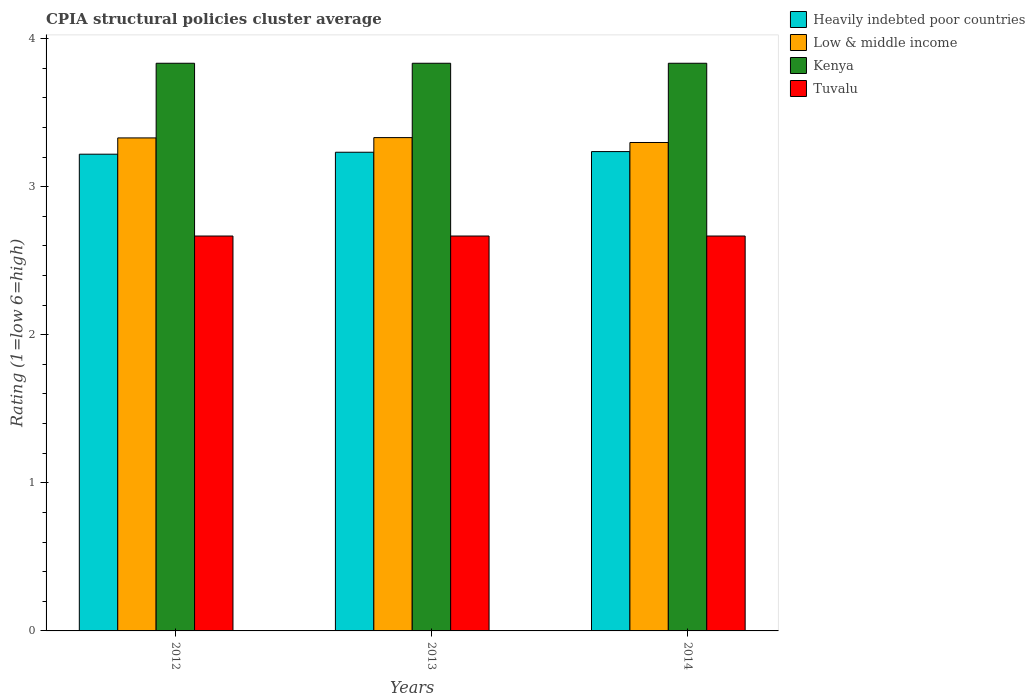How many different coloured bars are there?
Your answer should be very brief. 4. Are the number of bars per tick equal to the number of legend labels?
Your answer should be compact. Yes. How many bars are there on the 2nd tick from the right?
Give a very brief answer. 4. In how many cases, is the number of bars for a given year not equal to the number of legend labels?
Offer a terse response. 0. What is the CPIA rating in Low & middle income in 2012?
Your answer should be very brief. 3.33. Across all years, what is the maximum CPIA rating in Kenya?
Offer a terse response. 3.83. Across all years, what is the minimum CPIA rating in Kenya?
Your answer should be compact. 3.83. What is the total CPIA rating in Kenya in the graph?
Keep it short and to the point. 11.5. What is the difference between the CPIA rating in Tuvalu in 2013 and that in 2014?
Offer a terse response. -3.333333329802457e-6. What is the difference between the CPIA rating in Kenya in 2014 and the CPIA rating in Tuvalu in 2012?
Offer a very short reply. 1.17. What is the average CPIA rating in Heavily indebted poor countries per year?
Make the answer very short. 3.23. In the year 2014, what is the difference between the CPIA rating in Tuvalu and CPIA rating in Heavily indebted poor countries?
Offer a very short reply. -0.57. In how many years, is the CPIA rating in Tuvalu greater than 1.2?
Keep it short and to the point. 3. What is the ratio of the CPIA rating in Kenya in 2012 to that in 2013?
Your response must be concise. 1. Is the difference between the CPIA rating in Tuvalu in 2012 and 2014 greater than the difference between the CPIA rating in Heavily indebted poor countries in 2012 and 2014?
Your answer should be very brief. Yes. What is the difference between the highest and the lowest CPIA rating in Low & middle income?
Make the answer very short. 0.03. What does the 4th bar from the left in 2012 represents?
Provide a short and direct response. Tuvalu. What does the 2nd bar from the right in 2013 represents?
Give a very brief answer. Kenya. Is it the case that in every year, the sum of the CPIA rating in Low & middle income and CPIA rating in Tuvalu is greater than the CPIA rating in Heavily indebted poor countries?
Your answer should be very brief. Yes. Are all the bars in the graph horizontal?
Provide a succinct answer. No. Does the graph contain grids?
Provide a succinct answer. No. Where does the legend appear in the graph?
Offer a terse response. Top right. What is the title of the graph?
Provide a succinct answer. CPIA structural policies cluster average. What is the label or title of the Y-axis?
Give a very brief answer. Rating (1=low 6=high). What is the Rating (1=low 6=high) in Heavily indebted poor countries in 2012?
Give a very brief answer. 3.22. What is the Rating (1=low 6=high) of Low & middle income in 2012?
Provide a short and direct response. 3.33. What is the Rating (1=low 6=high) in Kenya in 2012?
Provide a short and direct response. 3.83. What is the Rating (1=low 6=high) in Tuvalu in 2012?
Offer a terse response. 2.67. What is the Rating (1=low 6=high) of Heavily indebted poor countries in 2013?
Your answer should be compact. 3.23. What is the Rating (1=low 6=high) in Low & middle income in 2013?
Provide a succinct answer. 3.33. What is the Rating (1=low 6=high) of Kenya in 2013?
Your response must be concise. 3.83. What is the Rating (1=low 6=high) of Tuvalu in 2013?
Provide a succinct answer. 2.67. What is the Rating (1=low 6=high) of Heavily indebted poor countries in 2014?
Keep it short and to the point. 3.24. What is the Rating (1=low 6=high) of Low & middle income in 2014?
Offer a terse response. 3.3. What is the Rating (1=low 6=high) of Kenya in 2014?
Offer a very short reply. 3.83. What is the Rating (1=low 6=high) in Tuvalu in 2014?
Provide a succinct answer. 2.67. Across all years, what is the maximum Rating (1=low 6=high) of Heavily indebted poor countries?
Your answer should be very brief. 3.24. Across all years, what is the maximum Rating (1=low 6=high) in Low & middle income?
Keep it short and to the point. 3.33. Across all years, what is the maximum Rating (1=low 6=high) in Kenya?
Ensure brevity in your answer.  3.83. Across all years, what is the maximum Rating (1=low 6=high) in Tuvalu?
Give a very brief answer. 2.67. Across all years, what is the minimum Rating (1=low 6=high) in Heavily indebted poor countries?
Offer a terse response. 3.22. Across all years, what is the minimum Rating (1=low 6=high) in Low & middle income?
Offer a very short reply. 3.3. Across all years, what is the minimum Rating (1=low 6=high) in Kenya?
Keep it short and to the point. 3.83. Across all years, what is the minimum Rating (1=low 6=high) in Tuvalu?
Your answer should be compact. 2.67. What is the total Rating (1=low 6=high) in Heavily indebted poor countries in the graph?
Ensure brevity in your answer.  9.69. What is the total Rating (1=low 6=high) of Low & middle income in the graph?
Keep it short and to the point. 9.96. What is the total Rating (1=low 6=high) of Kenya in the graph?
Ensure brevity in your answer.  11.5. What is the total Rating (1=low 6=high) in Tuvalu in the graph?
Keep it short and to the point. 8. What is the difference between the Rating (1=low 6=high) in Heavily indebted poor countries in 2012 and that in 2013?
Your response must be concise. -0.01. What is the difference between the Rating (1=low 6=high) in Low & middle income in 2012 and that in 2013?
Keep it short and to the point. -0. What is the difference between the Rating (1=low 6=high) of Kenya in 2012 and that in 2013?
Ensure brevity in your answer.  0. What is the difference between the Rating (1=low 6=high) in Tuvalu in 2012 and that in 2013?
Provide a short and direct response. 0. What is the difference between the Rating (1=low 6=high) of Heavily indebted poor countries in 2012 and that in 2014?
Give a very brief answer. -0.02. What is the difference between the Rating (1=low 6=high) in Low & middle income in 2012 and that in 2014?
Provide a succinct answer. 0.03. What is the difference between the Rating (1=low 6=high) of Heavily indebted poor countries in 2013 and that in 2014?
Your answer should be compact. -0. What is the difference between the Rating (1=low 6=high) of Low & middle income in 2013 and that in 2014?
Ensure brevity in your answer.  0.03. What is the difference between the Rating (1=low 6=high) of Tuvalu in 2013 and that in 2014?
Make the answer very short. -0. What is the difference between the Rating (1=low 6=high) in Heavily indebted poor countries in 2012 and the Rating (1=low 6=high) in Low & middle income in 2013?
Your answer should be compact. -0.11. What is the difference between the Rating (1=low 6=high) of Heavily indebted poor countries in 2012 and the Rating (1=low 6=high) of Kenya in 2013?
Offer a terse response. -0.61. What is the difference between the Rating (1=low 6=high) in Heavily indebted poor countries in 2012 and the Rating (1=low 6=high) in Tuvalu in 2013?
Your answer should be very brief. 0.55. What is the difference between the Rating (1=low 6=high) of Low & middle income in 2012 and the Rating (1=low 6=high) of Kenya in 2013?
Keep it short and to the point. -0.5. What is the difference between the Rating (1=low 6=high) in Low & middle income in 2012 and the Rating (1=low 6=high) in Tuvalu in 2013?
Ensure brevity in your answer.  0.66. What is the difference between the Rating (1=low 6=high) of Kenya in 2012 and the Rating (1=low 6=high) of Tuvalu in 2013?
Keep it short and to the point. 1.17. What is the difference between the Rating (1=low 6=high) of Heavily indebted poor countries in 2012 and the Rating (1=low 6=high) of Low & middle income in 2014?
Your answer should be very brief. -0.08. What is the difference between the Rating (1=low 6=high) of Heavily indebted poor countries in 2012 and the Rating (1=low 6=high) of Kenya in 2014?
Provide a short and direct response. -0.61. What is the difference between the Rating (1=low 6=high) in Heavily indebted poor countries in 2012 and the Rating (1=low 6=high) in Tuvalu in 2014?
Offer a terse response. 0.55. What is the difference between the Rating (1=low 6=high) of Low & middle income in 2012 and the Rating (1=low 6=high) of Kenya in 2014?
Offer a very short reply. -0.5. What is the difference between the Rating (1=low 6=high) in Low & middle income in 2012 and the Rating (1=low 6=high) in Tuvalu in 2014?
Provide a succinct answer. 0.66. What is the difference between the Rating (1=low 6=high) in Heavily indebted poor countries in 2013 and the Rating (1=low 6=high) in Low & middle income in 2014?
Your answer should be very brief. -0.07. What is the difference between the Rating (1=low 6=high) in Heavily indebted poor countries in 2013 and the Rating (1=low 6=high) in Kenya in 2014?
Give a very brief answer. -0.6. What is the difference between the Rating (1=low 6=high) in Heavily indebted poor countries in 2013 and the Rating (1=low 6=high) in Tuvalu in 2014?
Ensure brevity in your answer.  0.57. What is the difference between the Rating (1=low 6=high) in Low & middle income in 2013 and the Rating (1=low 6=high) in Kenya in 2014?
Your answer should be compact. -0.5. What is the difference between the Rating (1=low 6=high) of Low & middle income in 2013 and the Rating (1=low 6=high) of Tuvalu in 2014?
Provide a short and direct response. 0.66. What is the difference between the Rating (1=low 6=high) of Kenya in 2013 and the Rating (1=low 6=high) of Tuvalu in 2014?
Your answer should be very brief. 1.17. What is the average Rating (1=low 6=high) of Heavily indebted poor countries per year?
Provide a succinct answer. 3.23. What is the average Rating (1=low 6=high) in Low & middle income per year?
Give a very brief answer. 3.32. What is the average Rating (1=low 6=high) in Kenya per year?
Your response must be concise. 3.83. What is the average Rating (1=low 6=high) of Tuvalu per year?
Your answer should be compact. 2.67. In the year 2012, what is the difference between the Rating (1=low 6=high) of Heavily indebted poor countries and Rating (1=low 6=high) of Low & middle income?
Give a very brief answer. -0.11. In the year 2012, what is the difference between the Rating (1=low 6=high) in Heavily indebted poor countries and Rating (1=low 6=high) in Kenya?
Your response must be concise. -0.61. In the year 2012, what is the difference between the Rating (1=low 6=high) of Heavily indebted poor countries and Rating (1=low 6=high) of Tuvalu?
Your answer should be very brief. 0.55. In the year 2012, what is the difference between the Rating (1=low 6=high) in Low & middle income and Rating (1=low 6=high) in Kenya?
Keep it short and to the point. -0.5. In the year 2012, what is the difference between the Rating (1=low 6=high) of Low & middle income and Rating (1=low 6=high) of Tuvalu?
Provide a short and direct response. 0.66. In the year 2012, what is the difference between the Rating (1=low 6=high) in Kenya and Rating (1=low 6=high) in Tuvalu?
Provide a short and direct response. 1.17. In the year 2013, what is the difference between the Rating (1=low 6=high) in Heavily indebted poor countries and Rating (1=low 6=high) in Low & middle income?
Offer a terse response. -0.1. In the year 2013, what is the difference between the Rating (1=low 6=high) in Heavily indebted poor countries and Rating (1=low 6=high) in Kenya?
Your answer should be compact. -0.6. In the year 2013, what is the difference between the Rating (1=low 6=high) in Heavily indebted poor countries and Rating (1=low 6=high) in Tuvalu?
Provide a short and direct response. 0.57. In the year 2013, what is the difference between the Rating (1=low 6=high) of Low & middle income and Rating (1=low 6=high) of Kenya?
Ensure brevity in your answer.  -0.5. In the year 2013, what is the difference between the Rating (1=low 6=high) of Low & middle income and Rating (1=low 6=high) of Tuvalu?
Make the answer very short. 0.66. In the year 2013, what is the difference between the Rating (1=low 6=high) in Kenya and Rating (1=low 6=high) in Tuvalu?
Make the answer very short. 1.17. In the year 2014, what is the difference between the Rating (1=low 6=high) of Heavily indebted poor countries and Rating (1=low 6=high) of Low & middle income?
Your answer should be compact. -0.06. In the year 2014, what is the difference between the Rating (1=low 6=high) of Heavily indebted poor countries and Rating (1=low 6=high) of Kenya?
Make the answer very short. -0.6. In the year 2014, what is the difference between the Rating (1=low 6=high) in Heavily indebted poor countries and Rating (1=low 6=high) in Tuvalu?
Keep it short and to the point. 0.57. In the year 2014, what is the difference between the Rating (1=low 6=high) of Low & middle income and Rating (1=low 6=high) of Kenya?
Ensure brevity in your answer.  -0.54. In the year 2014, what is the difference between the Rating (1=low 6=high) of Low & middle income and Rating (1=low 6=high) of Tuvalu?
Make the answer very short. 0.63. What is the ratio of the Rating (1=low 6=high) in Heavily indebted poor countries in 2012 to that in 2013?
Provide a short and direct response. 1. What is the ratio of the Rating (1=low 6=high) in Low & middle income in 2012 to that in 2013?
Your answer should be compact. 1. What is the ratio of the Rating (1=low 6=high) in Low & middle income in 2012 to that in 2014?
Your response must be concise. 1.01. What is the ratio of the Rating (1=low 6=high) in Kenya in 2012 to that in 2014?
Provide a succinct answer. 1. What is the ratio of the Rating (1=low 6=high) of Tuvalu in 2012 to that in 2014?
Provide a short and direct response. 1. What is the ratio of the Rating (1=low 6=high) of Low & middle income in 2013 to that in 2014?
Your response must be concise. 1.01. What is the ratio of the Rating (1=low 6=high) in Tuvalu in 2013 to that in 2014?
Keep it short and to the point. 1. What is the difference between the highest and the second highest Rating (1=low 6=high) in Heavily indebted poor countries?
Offer a terse response. 0. What is the difference between the highest and the second highest Rating (1=low 6=high) of Low & middle income?
Keep it short and to the point. 0. What is the difference between the highest and the second highest Rating (1=low 6=high) in Kenya?
Your response must be concise. 0. What is the difference between the highest and the lowest Rating (1=low 6=high) of Heavily indebted poor countries?
Give a very brief answer. 0.02. What is the difference between the highest and the lowest Rating (1=low 6=high) of Low & middle income?
Provide a short and direct response. 0.03. What is the difference between the highest and the lowest Rating (1=low 6=high) of Kenya?
Give a very brief answer. 0. What is the difference between the highest and the lowest Rating (1=low 6=high) in Tuvalu?
Offer a very short reply. 0. 